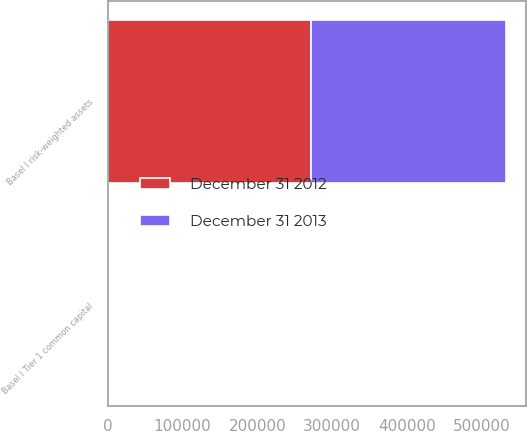Convert chart. <chart><loc_0><loc_0><loc_500><loc_500><stacked_bar_chart><ecel><fcel>Basel I Tier 1 common capital<fcel>Basel I risk-weighted assets<nl><fcel>December 31 2012<fcel>10.5<fcel>272169<nl><fcel>December 31 2013<fcel>9.6<fcel>260847<nl></chart> 